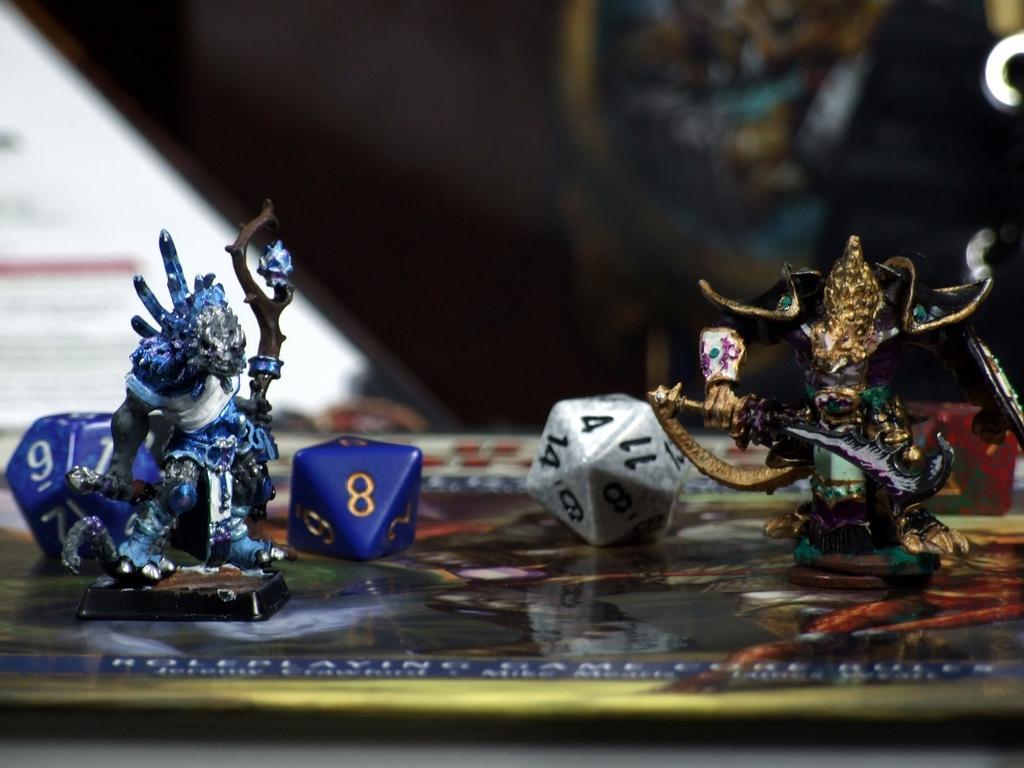How would you summarize this image in a sentence or two? In this image in the center there are some toys, and at the bottom it looks like a plate and in the background there are some objects. 